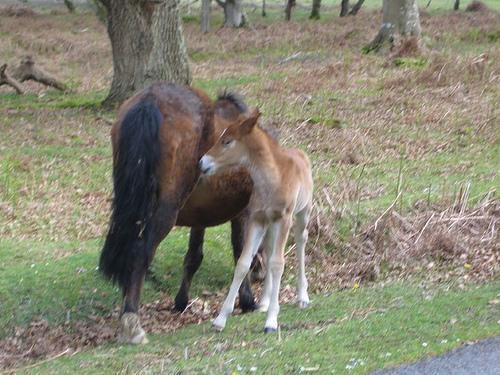How many animals are there?
Give a very brief answer. 2. How many horses are there?
Give a very brief answer. 2. 